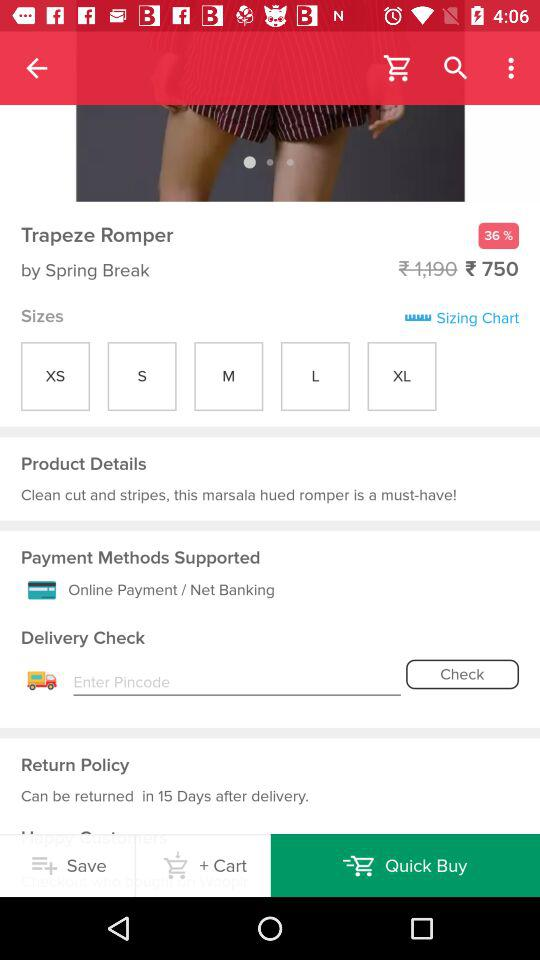What are the sizes available? The sizes available are : "XS", "S", "M", "L", and "XL". 